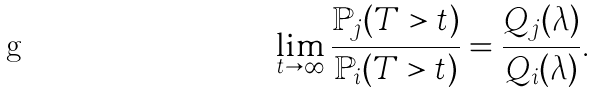<formula> <loc_0><loc_0><loc_500><loc_500>\lim _ { t \rightarrow \infty } \frac { \mathbb { P } _ { j } ( T > t ) } { \mathbb { P } _ { i } ( T > t ) } = \frac { Q _ { j } ( \lambda ) } { Q _ { i } ( \lambda ) } .</formula> 